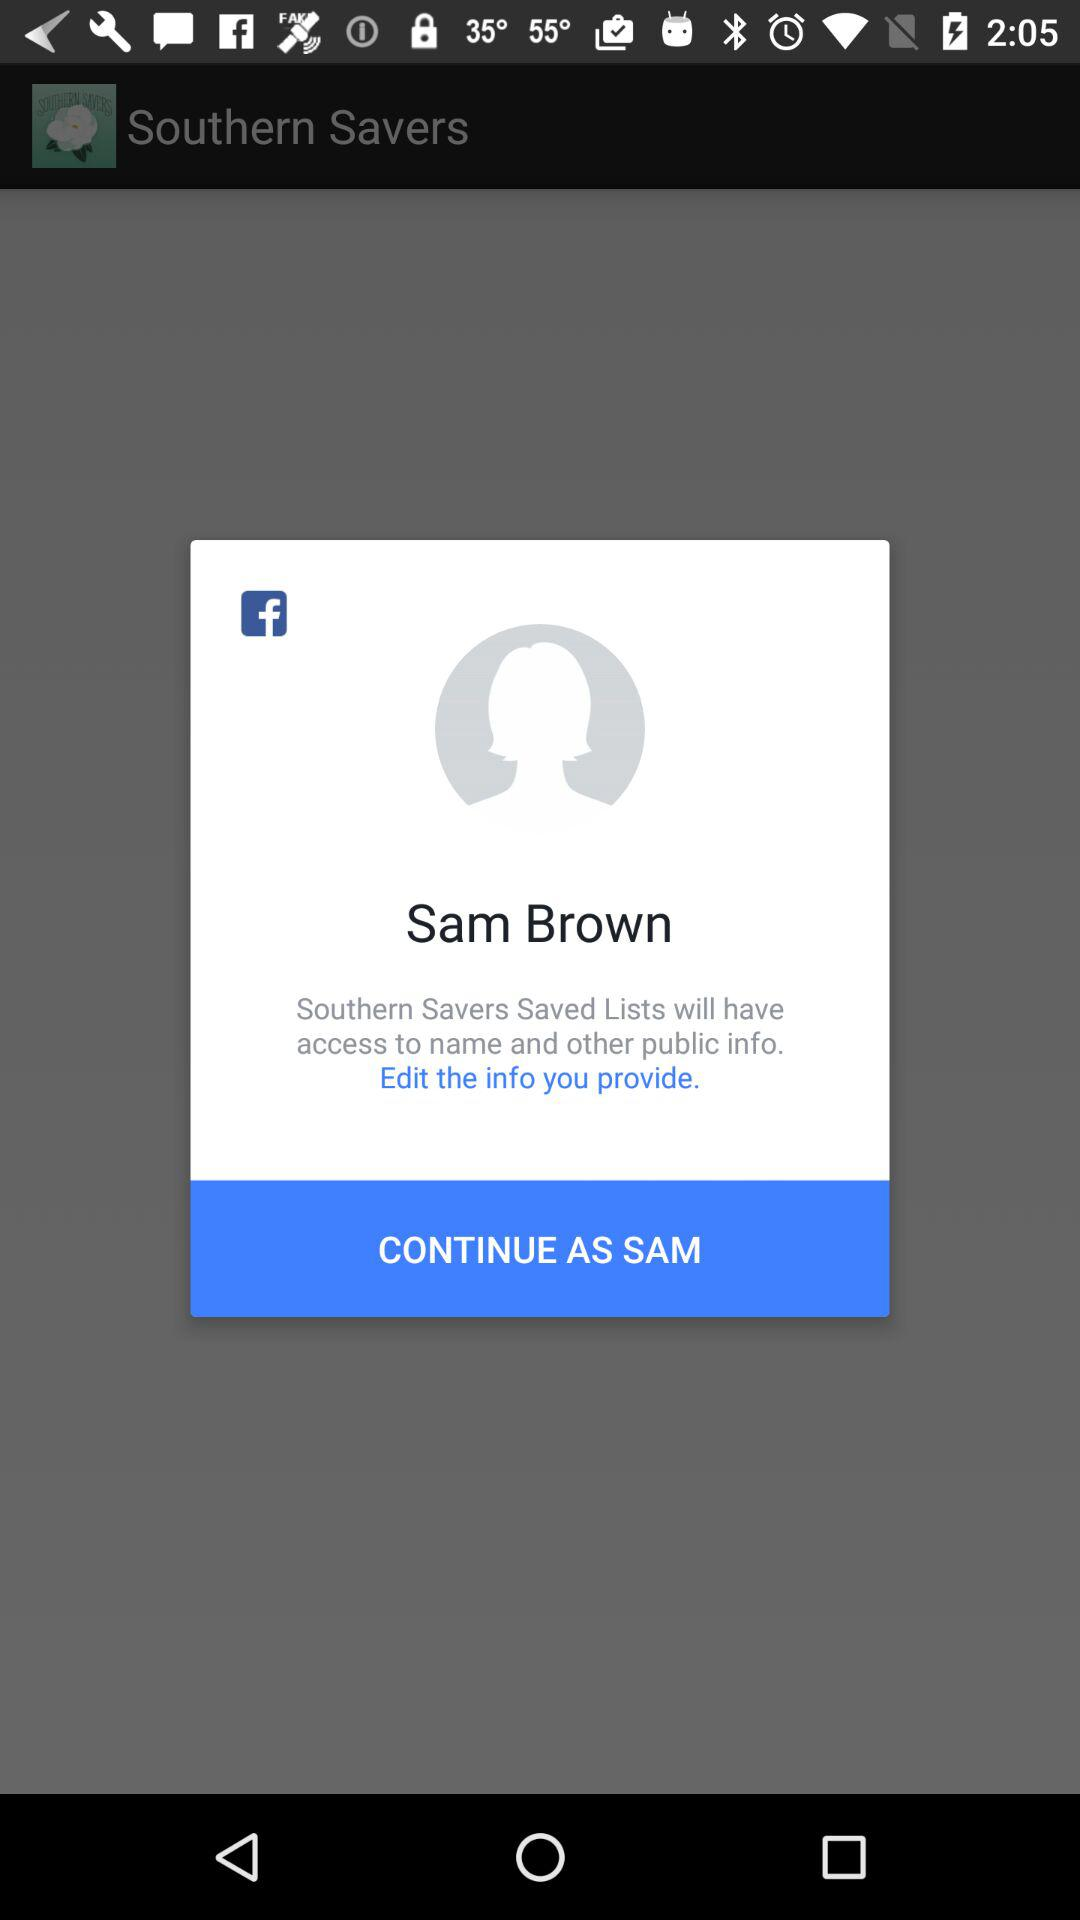What application will have access to the name and other public info.? The application "Southern Savers Saved Lists" will have access to the name and other public information. 